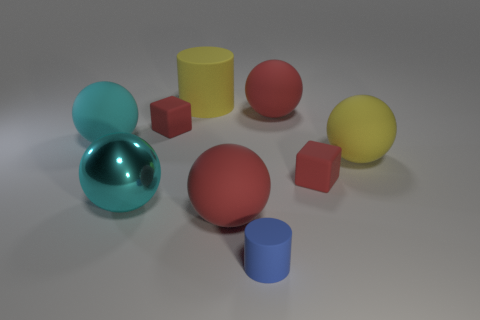Subtract all brown spheres. Subtract all purple blocks. How many spheres are left? 5 Subtract all cylinders. How many objects are left? 7 Add 1 blue rubber objects. How many blue rubber objects exist? 2 Subtract 0 brown blocks. How many objects are left? 9 Subtract all yellow matte spheres. Subtract all big yellow matte cylinders. How many objects are left? 7 Add 7 blocks. How many blocks are left? 9 